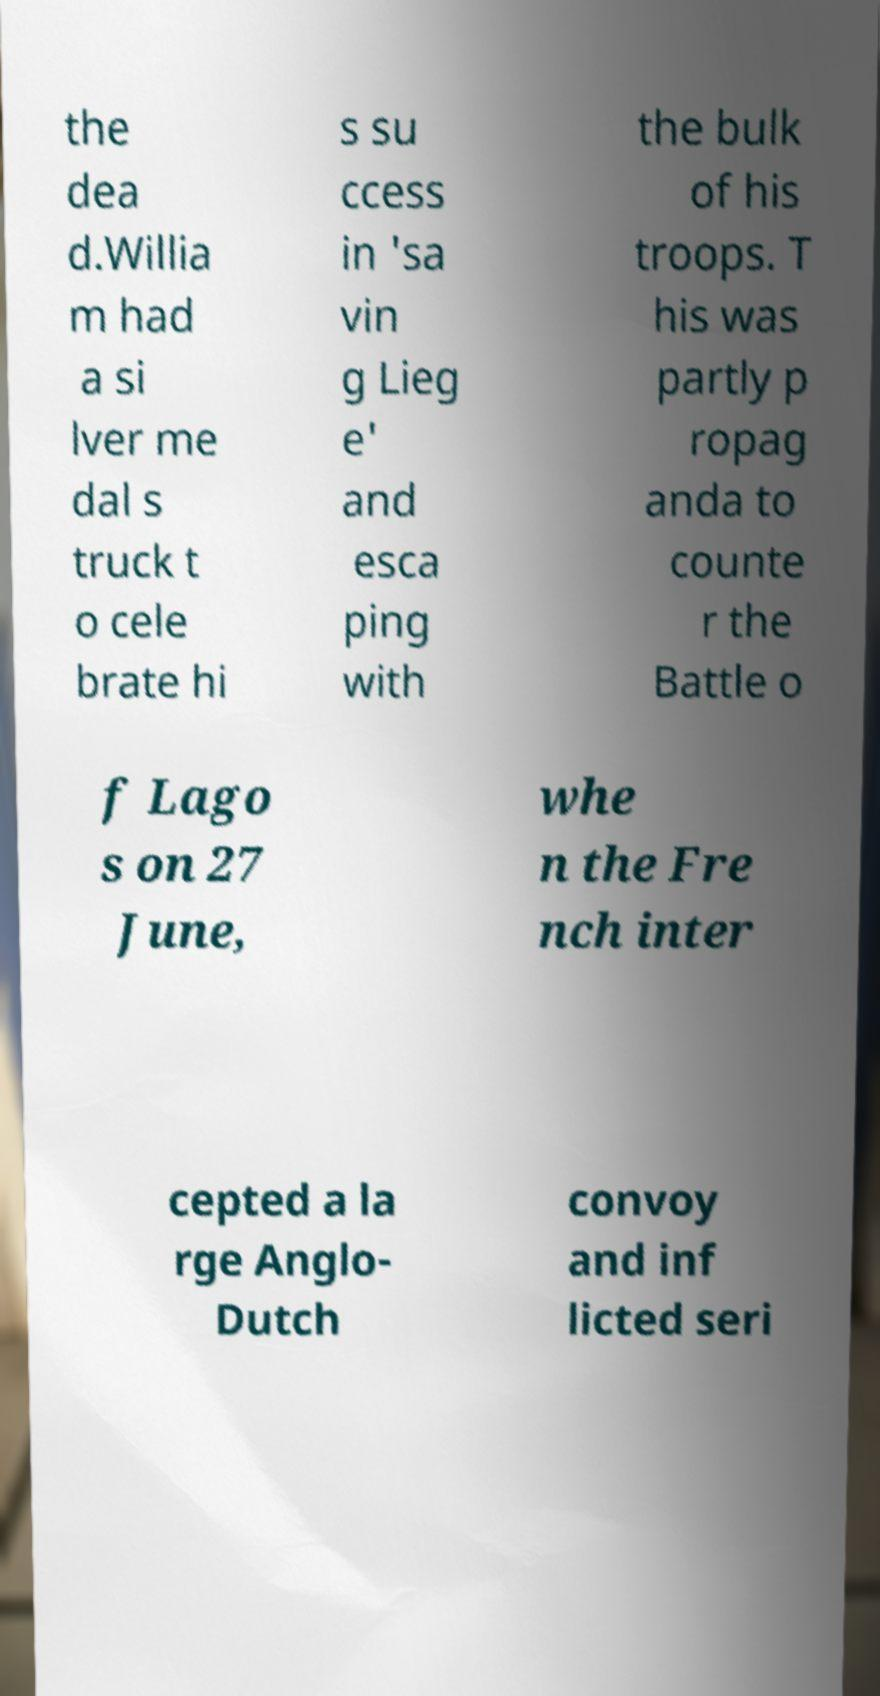What messages or text are displayed in this image? I need them in a readable, typed format. the dea d.Willia m had a si lver me dal s truck t o cele brate hi s su ccess in 'sa vin g Lieg e' and esca ping with the bulk of his troops. T his was partly p ropag anda to counte r the Battle o f Lago s on 27 June, whe n the Fre nch inter cepted a la rge Anglo- Dutch convoy and inf licted seri 